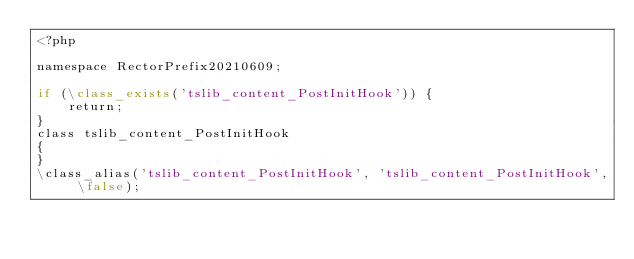<code> <loc_0><loc_0><loc_500><loc_500><_PHP_><?php

namespace RectorPrefix20210609;

if (\class_exists('tslib_content_PostInitHook')) {
    return;
}
class tslib_content_PostInitHook
{
}
\class_alias('tslib_content_PostInitHook', 'tslib_content_PostInitHook', \false);
</code> 